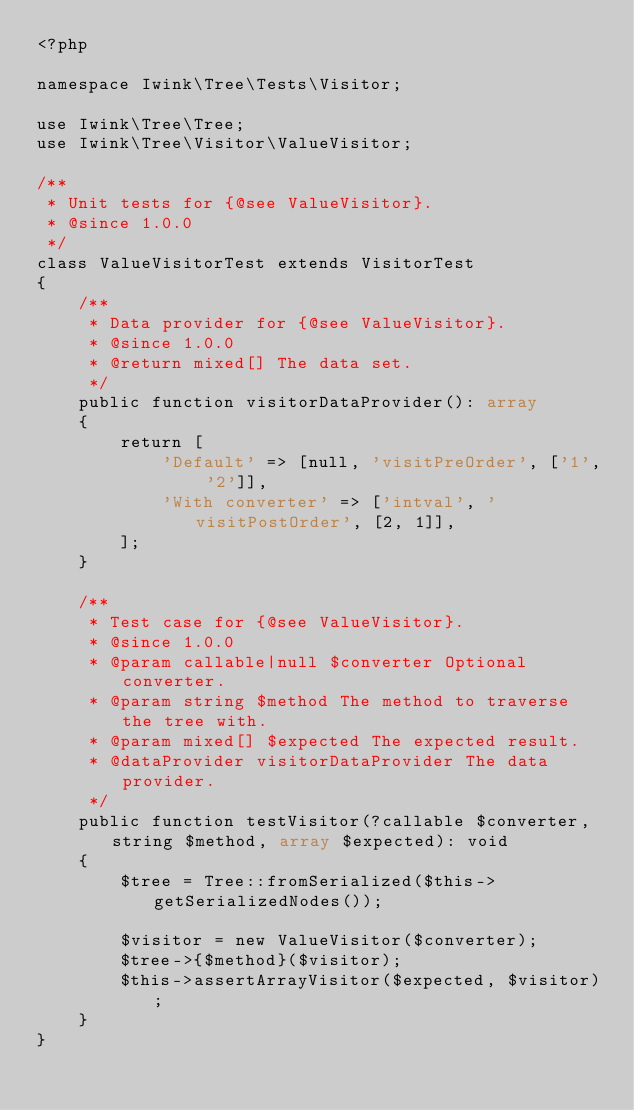Convert code to text. <code><loc_0><loc_0><loc_500><loc_500><_PHP_><?php

namespace Iwink\Tree\Tests\Visitor;

use Iwink\Tree\Tree;
use Iwink\Tree\Visitor\ValueVisitor;

/**
 * Unit tests for {@see ValueVisitor}.
 * @since 1.0.0
 */
class ValueVisitorTest extends VisitorTest
{
    /**
     * Data provider for {@see ValueVisitor}.
     * @since 1.0.0
     * @return mixed[] The data set.
     */
    public function visitorDataProvider(): array
    {
        return [
            'Default' => [null, 'visitPreOrder', ['1', '2']],
            'With converter' => ['intval', 'visitPostOrder', [2, 1]],
        ];
    }

    /**
     * Test case for {@see ValueVisitor}.
     * @since 1.0.0
     * @param callable|null $converter Optional converter.
     * @param string $method The method to traverse the tree with.
     * @param mixed[] $expected The expected result.
     * @dataProvider visitorDataProvider The data provider.
     */
    public function testVisitor(?callable $converter, string $method, array $expected): void
    {
        $tree = Tree::fromSerialized($this->getSerializedNodes());

        $visitor = new ValueVisitor($converter);
        $tree->{$method}($visitor);
        $this->assertArrayVisitor($expected, $visitor);
    }
}
</code> 